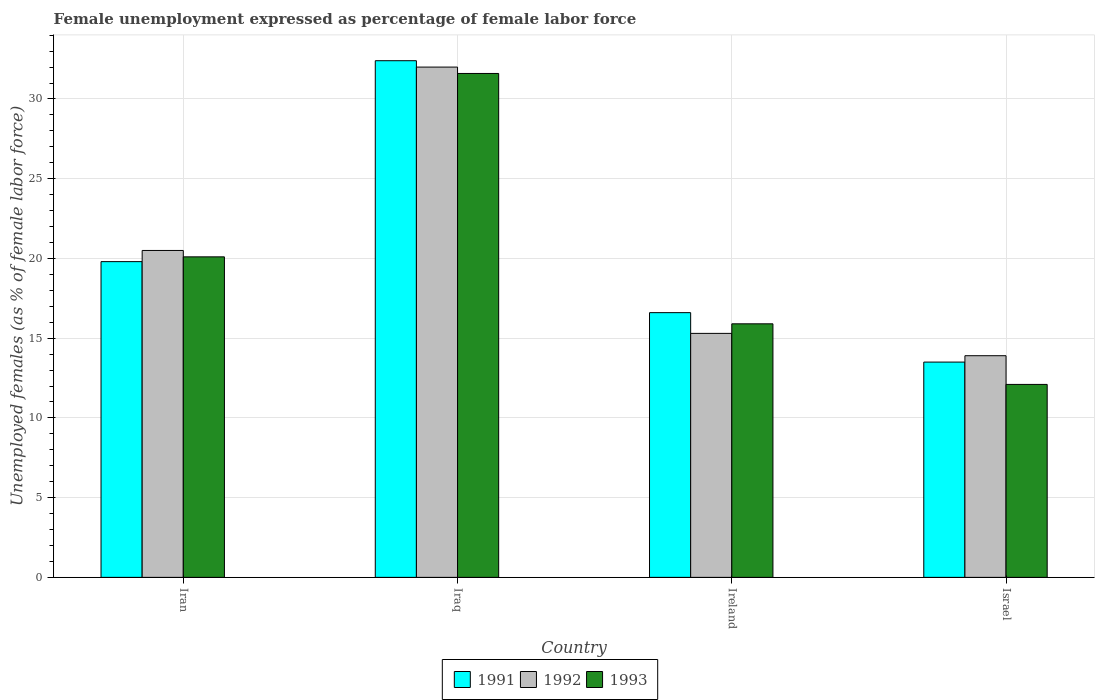How many different coloured bars are there?
Your answer should be compact. 3. How many groups of bars are there?
Provide a succinct answer. 4. How many bars are there on the 2nd tick from the left?
Keep it short and to the point. 3. How many bars are there on the 2nd tick from the right?
Keep it short and to the point. 3. What is the label of the 1st group of bars from the left?
Ensure brevity in your answer.  Iran. What is the unemployment in females in in 1992 in Iraq?
Your answer should be compact. 32. Across all countries, what is the maximum unemployment in females in in 1993?
Your response must be concise. 31.6. Across all countries, what is the minimum unemployment in females in in 1991?
Your answer should be compact. 13.5. In which country was the unemployment in females in in 1993 maximum?
Keep it short and to the point. Iraq. What is the total unemployment in females in in 1993 in the graph?
Give a very brief answer. 79.7. What is the difference between the unemployment in females in in 1993 in Iraq and that in Ireland?
Provide a short and direct response. 15.7. What is the difference between the unemployment in females in in 1993 in Ireland and the unemployment in females in in 1991 in Israel?
Offer a terse response. 2.4. What is the average unemployment in females in in 1991 per country?
Offer a terse response. 20.58. What is the difference between the unemployment in females in of/in 1992 and unemployment in females in of/in 1993 in Israel?
Offer a very short reply. 1.8. In how many countries, is the unemployment in females in in 1993 greater than 13 %?
Offer a terse response. 3. What is the ratio of the unemployment in females in in 1992 in Iraq to that in Ireland?
Your response must be concise. 2.09. Is the unemployment in females in in 1993 in Iran less than that in Israel?
Ensure brevity in your answer.  No. Is the difference between the unemployment in females in in 1992 in Iran and Iraq greater than the difference between the unemployment in females in in 1993 in Iran and Iraq?
Keep it short and to the point. No. What is the difference between the highest and the second highest unemployment in females in in 1993?
Your response must be concise. -4.2. What is the difference between the highest and the lowest unemployment in females in in 1993?
Make the answer very short. 19.5. In how many countries, is the unemployment in females in in 1993 greater than the average unemployment in females in in 1993 taken over all countries?
Your answer should be very brief. 2. What does the 1st bar from the right in Israel represents?
Provide a succinct answer. 1993. Is it the case that in every country, the sum of the unemployment in females in in 1993 and unemployment in females in in 1992 is greater than the unemployment in females in in 1991?
Provide a short and direct response. Yes. Does the graph contain any zero values?
Provide a short and direct response. No. Where does the legend appear in the graph?
Keep it short and to the point. Bottom center. What is the title of the graph?
Offer a very short reply. Female unemployment expressed as percentage of female labor force. What is the label or title of the Y-axis?
Offer a terse response. Unemployed females (as % of female labor force). What is the Unemployed females (as % of female labor force) in 1991 in Iran?
Offer a terse response. 19.8. What is the Unemployed females (as % of female labor force) of 1992 in Iran?
Give a very brief answer. 20.5. What is the Unemployed females (as % of female labor force) in 1993 in Iran?
Offer a very short reply. 20.1. What is the Unemployed females (as % of female labor force) in 1991 in Iraq?
Your answer should be very brief. 32.4. What is the Unemployed females (as % of female labor force) in 1992 in Iraq?
Make the answer very short. 32. What is the Unemployed females (as % of female labor force) in 1993 in Iraq?
Give a very brief answer. 31.6. What is the Unemployed females (as % of female labor force) of 1991 in Ireland?
Your answer should be compact. 16.6. What is the Unemployed females (as % of female labor force) of 1992 in Ireland?
Offer a very short reply. 15.3. What is the Unemployed females (as % of female labor force) of 1993 in Ireland?
Offer a terse response. 15.9. What is the Unemployed females (as % of female labor force) of 1992 in Israel?
Offer a very short reply. 13.9. What is the Unemployed females (as % of female labor force) of 1993 in Israel?
Your answer should be very brief. 12.1. Across all countries, what is the maximum Unemployed females (as % of female labor force) of 1991?
Your answer should be very brief. 32.4. Across all countries, what is the maximum Unemployed females (as % of female labor force) in 1993?
Your answer should be compact. 31.6. Across all countries, what is the minimum Unemployed females (as % of female labor force) of 1991?
Make the answer very short. 13.5. Across all countries, what is the minimum Unemployed females (as % of female labor force) in 1992?
Provide a short and direct response. 13.9. Across all countries, what is the minimum Unemployed females (as % of female labor force) in 1993?
Your response must be concise. 12.1. What is the total Unemployed females (as % of female labor force) of 1991 in the graph?
Keep it short and to the point. 82.3. What is the total Unemployed females (as % of female labor force) in 1992 in the graph?
Keep it short and to the point. 81.7. What is the total Unemployed females (as % of female labor force) of 1993 in the graph?
Your response must be concise. 79.7. What is the difference between the Unemployed females (as % of female labor force) in 1991 in Iran and that in Iraq?
Your answer should be very brief. -12.6. What is the difference between the Unemployed females (as % of female labor force) of 1993 in Iran and that in Iraq?
Provide a short and direct response. -11.5. What is the difference between the Unemployed females (as % of female labor force) of 1991 in Iran and that in Ireland?
Your response must be concise. 3.2. What is the difference between the Unemployed females (as % of female labor force) of 1991 in Iran and that in Israel?
Offer a very short reply. 6.3. What is the difference between the Unemployed females (as % of female labor force) in 1992 in Iran and that in Israel?
Give a very brief answer. 6.6. What is the difference between the Unemployed females (as % of female labor force) in 1993 in Iran and that in Israel?
Your answer should be very brief. 8. What is the difference between the Unemployed females (as % of female labor force) of 1992 in Iraq and that in Israel?
Keep it short and to the point. 18.1. What is the difference between the Unemployed females (as % of female labor force) of 1993 in Iraq and that in Israel?
Provide a succinct answer. 19.5. What is the difference between the Unemployed females (as % of female labor force) in 1991 in Ireland and that in Israel?
Keep it short and to the point. 3.1. What is the difference between the Unemployed females (as % of female labor force) in 1991 in Iran and the Unemployed females (as % of female labor force) in 1992 in Iraq?
Your answer should be very brief. -12.2. What is the difference between the Unemployed females (as % of female labor force) in 1991 in Iran and the Unemployed females (as % of female labor force) in 1993 in Ireland?
Your answer should be very brief. 3.9. What is the difference between the Unemployed females (as % of female labor force) in 1991 in Iran and the Unemployed females (as % of female labor force) in 1992 in Israel?
Your answer should be very brief. 5.9. What is the difference between the Unemployed females (as % of female labor force) in 1991 in Iraq and the Unemployed females (as % of female labor force) in 1993 in Ireland?
Ensure brevity in your answer.  16.5. What is the difference between the Unemployed females (as % of female labor force) in 1991 in Iraq and the Unemployed females (as % of female labor force) in 1992 in Israel?
Offer a terse response. 18.5. What is the difference between the Unemployed females (as % of female labor force) in 1991 in Iraq and the Unemployed females (as % of female labor force) in 1993 in Israel?
Offer a very short reply. 20.3. What is the difference between the Unemployed females (as % of female labor force) in 1992 in Iraq and the Unemployed females (as % of female labor force) in 1993 in Israel?
Keep it short and to the point. 19.9. What is the difference between the Unemployed females (as % of female labor force) in 1991 in Ireland and the Unemployed females (as % of female labor force) in 1992 in Israel?
Your response must be concise. 2.7. What is the difference between the Unemployed females (as % of female labor force) of 1991 in Ireland and the Unemployed females (as % of female labor force) of 1993 in Israel?
Your answer should be very brief. 4.5. What is the average Unemployed females (as % of female labor force) of 1991 per country?
Your response must be concise. 20.57. What is the average Unemployed females (as % of female labor force) in 1992 per country?
Provide a short and direct response. 20.43. What is the average Unemployed females (as % of female labor force) of 1993 per country?
Your answer should be compact. 19.93. What is the difference between the Unemployed females (as % of female labor force) in 1991 and Unemployed females (as % of female labor force) in 1992 in Iraq?
Your answer should be very brief. 0.4. What is the difference between the Unemployed females (as % of female labor force) of 1992 and Unemployed females (as % of female labor force) of 1993 in Iraq?
Provide a short and direct response. 0.4. What is the difference between the Unemployed females (as % of female labor force) in 1991 and Unemployed females (as % of female labor force) in 1992 in Ireland?
Offer a very short reply. 1.3. What is the difference between the Unemployed females (as % of female labor force) of 1991 and Unemployed females (as % of female labor force) of 1992 in Israel?
Offer a terse response. -0.4. What is the difference between the Unemployed females (as % of female labor force) of 1992 and Unemployed females (as % of female labor force) of 1993 in Israel?
Your answer should be compact. 1.8. What is the ratio of the Unemployed females (as % of female labor force) of 1991 in Iran to that in Iraq?
Ensure brevity in your answer.  0.61. What is the ratio of the Unemployed females (as % of female labor force) of 1992 in Iran to that in Iraq?
Your answer should be compact. 0.64. What is the ratio of the Unemployed females (as % of female labor force) of 1993 in Iran to that in Iraq?
Provide a short and direct response. 0.64. What is the ratio of the Unemployed females (as % of female labor force) in 1991 in Iran to that in Ireland?
Provide a succinct answer. 1.19. What is the ratio of the Unemployed females (as % of female labor force) in 1992 in Iran to that in Ireland?
Ensure brevity in your answer.  1.34. What is the ratio of the Unemployed females (as % of female labor force) in 1993 in Iran to that in Ireland?
Make the answer very short. 1.26. What is the ratio of the Unemployed females (as % of female labor force) in 1991 in Iran to that in Israel?
Offer a terse response. 1.47. What is the ratio of the Unemployed females (as % of female labor force) in 1992 in Iran to that in Israel?
Provide a short and direct response. 1.47. What is the ratio of the Unemployed females (as % of female labor force) of 1993 in Iran to that in Israel?
Make the answer very short. 1.66. What is the ratio of the Unemployed females (as % of female labor force) of 1991 in Iraq to that in Ireland?
Make the answer very short. 1.95. What is the ratio of the Unemployed females (as % of female labor force) of 1992 in Iraq to that in Ireland?
Your answer should be compact. 2.09. What is the ratio of the Unemployed females (as % of female labor force) of 1993 in Iraq to that in Ireland?
Give a very brief answer. 1.99. What is the ratio of the Unemployed females (as % of female labor force) in 1992 in Iraq to that in Israel?
Your response must be concise. 2.3. What is the ratio of the Unemployed females (as % of female labor force) of 1993 in Iraq to that in Israel?
Your response must be concise. 2.61. What is the ratio of the Unemployed females (as % of female labor force) of 1991 in Ireland to that in Israel?
Offer a terse response. 1.23. What is the ratio of the Unemployed females (as % of female labor force) of 1992 in Ireland to that in Israel?
Your response must be concise. 1.1. What is the ratio of the Unemployed females (as % of female labor force) in 1993 in Ireland to that in Israel?
Your answer should be very brief. 1.31. What is the difference between the highest and the second highest Unemployed females (as % of female labor force) of 1991?
Your answer should be compact. 12.6. What is the difference between the highest and the second highest Unemployed females (as % of female labor force) of 1992?
Your answer should be very brief. 11.5. What is the difference between the highest and the second highest Unemployed females (as % of female labor force) of 1993?
Your response must be concise. 11.5. What is the difference between the highest and the lowest Unemployed females (as % of female labor force) of 1991?
Offer a very short reply. 18.9. What is the difference between the highest and the lowest Unemployed females (as % of female labor force) of 1992?
Offer a very short reply. 18.1. What is the difference between the highest and the lowest Unemployed females (as % of female labor force) in 1993?
Provide a short and direct response. 19.5. 